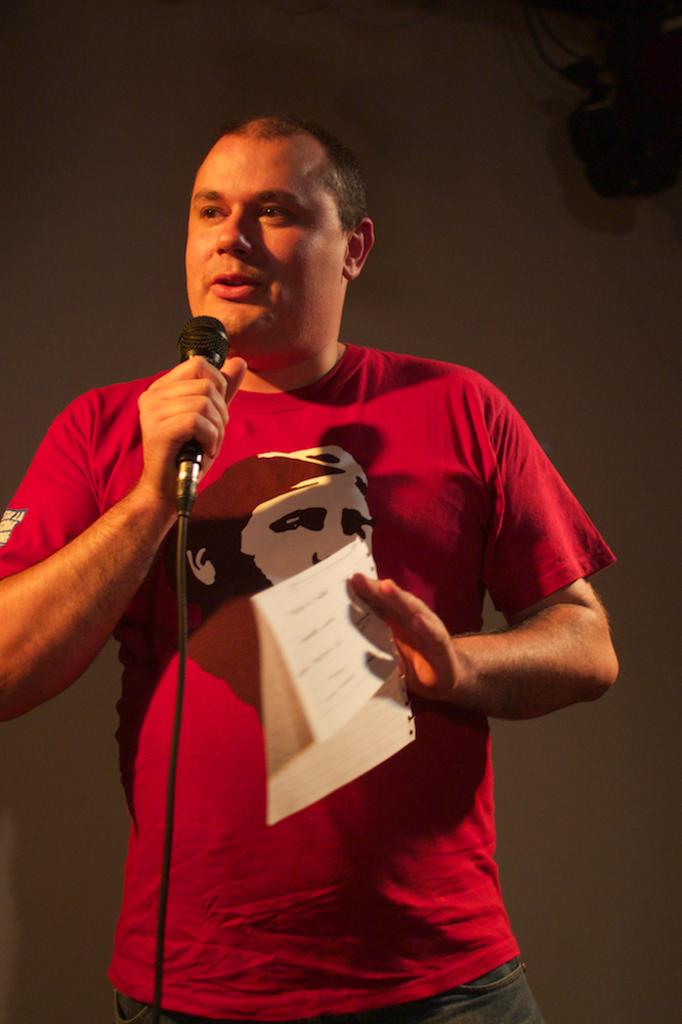What is the person in the image doing? The person is giving a speech. What object is the person holding in their hand while giving the speech? The person is holding a microphone in their hand. What else is the person holding in their other hand? The person is holding a paper in their other hand. What is the person wearing in the image? The person is wearing a red t-shirt. What can be seen in the background of the image? There is a wall in the background of the image. What type of cover is the person using to protect the microphone from the cat in the image? There is no cat present in the image, and therefore no need for a cover to protect the microphone. 